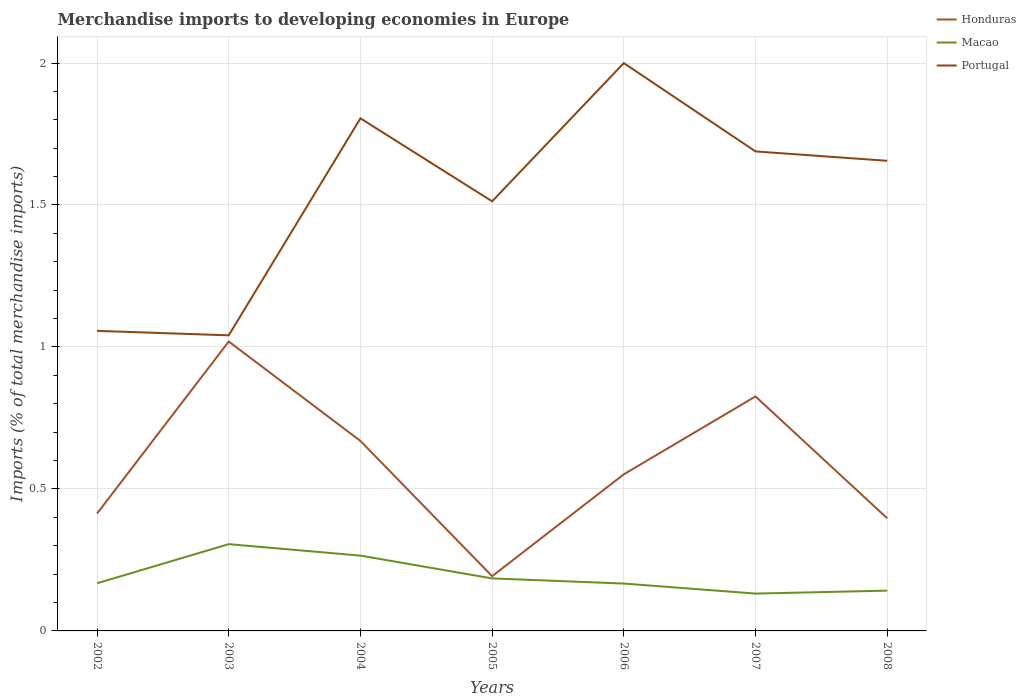How many different coloured lines are there?
Your response must be concise. 3. Does the line corresponding to Honduras intersect with the line corresponding to Portugal?
Your response must be concise. No. Across all years, what is the maximum percentage total merchandise imports in Portugal?
Your answer should be compact. 1.04. In which year was the percentage total merchandise imports in Honduras maximum?
Offer a terse response. 2005. What is the total percentage total merchandise imports in Macao in the graph?
Ensure brevity in your answer.  0.02. What is the difference between the highest and the second highest percentage total merchandise imports in Portugal?
Your answer should be compact. 0.96. What is the difference between the highest and the lowest percentage total merchandise imports in Portugal?
Make the answer very short. 4. Is the percentage total merchandise imports in Portugal strictly greater than the percentage total merchandise imports in Honduras over the years?
Ensure brevity in your answer.  No. How many years are there in the graph?
Give a very brief answer. 7. Does the graph contain any zero values?
Give a very brief answer. No. Where does the legend appear in the graph?
Your answer should be compact. Top right. How many legend labels are there?
Keep it short and to the point. 3. How are the legend labels stacked?
Ensure brevity in your answer.  Vertical. What is the title of the graph?
Make the answer very short. Merchandise imports to developing economies in Europe. What is the label or title of the Y-axis?
Provide a succinct answer. Imports (% of total merchandise imports). What is the Imports (% of total merchandise imports) in Honduras in 2002?
Make the answer very short. 0.41. What is the Imports (% of total merchandise imports) in Macao in 2002?
Keep it short and to the point. 0.17. What is the Imports (% of total merchandise imports) in Portugal in 2002?
Your answer should be very brief. 1.06. What is the Imports (% of total merchandise imports) in Honduras in 2003?
Offer a terse response. 1.02. What is the Imports (% of total merchandise imports) of Macao in 2003?
Provide a short and direct response. 0.31. What is the Imports (% of total merchandise imports) in Portugal in 2003?
Give a very brief answer. 1.04. What is the Imports (% of total merchandise imports) in Honduras in 2004?
Your answer should be compact. 0.67. What is the Imports (% of total merchandise imports) in Macao in 2004?
Make the answer very short. 0.27. What is the Imports (% of total merchandise imports) in Portugal in 2004?
Provide a succinct answer. 1.81. What is the Imports (% of total merchandise imports) in Honduras in 2005?
Offer a terse response. 0.19. What is the Imports (% of total merchandise imports) in Macao in 2005?
Give a very brief answer. 0.18. What is the Imports (% of total merchandise imports) in Portugal in 2005?
Make the answer very short. 1.51. What is the Imports (% of total merchandise imports) in Honduras in 2006?
Give a very brief answer. 0.55. What is the Imports (% of total merchandise imports) in Macao in 2006?
Make the answer very short. 0.17. What is the Imports (% of total merchandise imports) in Portugal in 2006?
Make the answer very short. 2. What is the Imports (% of total merchandise imports) in Honduras in 2007?
Offer a very short reply. 0.83. What is the Imports (% of total merchandise imports) in Macao in 2007?
Your answer should be compact. 0.13. What is the Imports (% of total merchandise imports) of Portugal in 2007?
Your answer should be very brief. 1.69. What is the Imports (% of total merchandise imports) in Honduras in 2008?
Make the answer very short. 0.4. What is the Imports (% of total merchandise imports) in Macao in 2008?
Your answer should be compact. 0.14. What is the Imports (% of total merchandise imports) in Portugal in 2008?
Provide a short and direct response. 1.66. Across all years, what is the maximum Imports (% of total merchandise imports) of Honduras?
Provide a succinct answer. 1.02. Across all years, what is the maximum Imports (% of total merchandise imports) in Macao?
Give a very brief answer. 0.31. Across all years, what is the maximum Imports (% of total merchandise imports) of Portugal?
Your answer should be very brief. 2. Across all years, what is the minimum Imports (% of total merchandise imports) in Honduras?
Your answer should be very brief. 0.19. Across all years, what is the minimum Imports (% of total merchandise imports) of Macao?
Provide a short and direct response. 0.13. Across all years, what is the minimum Imports (% of total merchandise imports) in Portugal?
Make the answer very short. 1.04. What is the total Imports (% of total merchandise imports) of Honduras in the graph?
Offer a very short reply. 4.07. What is the total Imports (% of total merchandise imports) in Macao in the graph?
Your answer should be very brief. 1.36. What is the total Imports (% of total merchandise imports) of Portugal in the graph?
Give a very brief answer. 10.76. What is the difference between the Imports (% of total merchandise imports) in Honduras in 2002 and that in 2003?
Keep it short and to the point. -0.61. What is the difference between the Imports (% of total merchandise imports) of Macao in 2002 and that in 2003?
Your answer should be compact. -0.14. What is the difference between the Imports (% of total merchandise imports) of Portugal in 2002 and that in 2003?
Make the answer very short. 0.02. What is the difference between the Imports (% of total merchandise imports) in Honduras in 2002 and that in 2004?
Make the answer very short. -0.26. What is the difference between the Imports (% of total merchandise imports) in Macao in 2002 and that in 2004?
Keep it short and to the point. -0.1. What is the difference between the Imports (% of total merchandise imports) of Portugal in 2002 and that in 2004?
Provide a short and direct response. -0.75. What is the difference between the Imports (% of total merchandise imports) in Honduras in 2002 and that in 2005?
Offer a terse response. 0.22. What is the difference between the Imports (% of total merchandise imports) in Macao in 2002 and that in 2005?
Keep it short and to the point. -0.02. What is the difference between the Imports (% of total merchandise imports) in Portugal in 2002 and that in 2005?
Provide a succinct answer. -0.46. What is the difference between the Imports (% of total merchandise imports) of Honduras in 2002 and that in 2006?
Your answer should be compact. -0.14. What is the difference between the Imports (% of total merchandise imports) in Macao in 2002 and that in 2006?
Offer a terse response. 0. What is the difference between the Imports (% of total merchandise imports) of Portugal in 2002 and that in 2006?
Offer a very short reply. -0.94. What is the difference between the Imports (% of total merchandise imports) in Honduras in 2002 and that in 2007?
Give a very brief answer. -0.41. What is the difference between the Imports (% of total merchandise imports) in Macao in 2002 and that in 2007?
Your answer should be compact. 0.04. What is the difference between the Imports (% of total merchandise imports) in Portugal in 2002 and that in 2007?
Provide a short and direct response. -0.63. What is the difference between the Imports (% of total merchandise imports) of Honduras in 2002 and that in 2008?
Provide a succinct answer. 0.02. What is the difference between the Imports (% of total merchandise imports) in Macao in 2002 and that in 2008?
Make the answer very short. 0.03. What is the difference between the Imports (% of total merchandise imports) in Portugal in 2002 and that in 2008?
Ensure brevity in your answer.  -0.6. What is the difference between the Imports (% of total merchandise imports) of Honduras in 2003 and that in 2004?
Offer a very short reply. 0.35. What is the difference between the Imports (% of total merchandise imports) in Macao in 2003 and that in 2004?
Your answer should be compact. 0.04. What is the difference between the Imports (% of total merchandise imports) in Portugal in 2003 and that in 2004?
Provide a succinct answer. -0.76. What is the difference between the Imports (% of total merchandise imports) of Honduras in 2003 and that in 2005?
Provide a short and direct response. 0.83. What is the difference between the Imports (% of total merchandise imports) in Macao in 2003 and that in 2005?
Your response must be concise. 0.12. What is the difference between the Imports (% of total merchandise imports) of Portugal in 2003 and that in 2005?
Your response must be concise. -0.47. What is the difference between the Imports (% of total merchandise imports) of Honduras in 2003 and that in 2006?
Offer a terse response. 0.47. What is the difference between the Imports (% of total merchandise imports) of Macao in 2003 and that in 2006?
Offer a terse response. 0.14. What is the difference between the Imports (% of total merchandise imports) of Portugal in 2003 and that in 2006?
Your answer should be very brief. -0.96. What is the difference between the Imports (% of total merchandise imports) of Honduras in 2003 and that in 2007?
Make the answer very short. 0.19. What is the difference between the Imports (% of total merchandise imports) in Macao in 2003 and that in 2007?
Your response must be concise. 0.17. What is the difference between the Imports (% of total merchandise imports) in Portugal in 2003 and that in 2007?
Your answer should be compact. -0.65. What is the difference between the Imports (% of total merchandise imports) in Honduras in 2003 and that in 2008?
Offer a terse response. 0.62. What is the difference between the Imports (% of total merchandise imports) in Macao in 2003 and that in 2008?
Keep it short and to the point. 0.16. What is the difference between the Imports (% of total merchandise imports) in Portugal in 2003 and that in 2008?
Provide a succinct answer. -0.61. What is the difference between the Imports (% of total merchandise imports) of Honduras in 2004 and that in 2005?
Offer a very short reply. 0.48. What is the difference between the Imports (% of total merchandise imports) of Macao in 2004 and that in 2005?
Offer a terse response. 0.08. What is the difference between the Imports (% of total merchandise imports) in Portugal in 2004 and that in 2005?
Provide a short and direct response. 0.29. What is the difference between the Imports (% of total merchandise imports) in Honduras in 2004 and that in 2006?
Make the answer very short. 0.12. What is the difference between the Imports (% of total merchandise imports) of Macao in 2004 and that in 2006?
Your answer should be compact. 0.1. What is the difference between the Imports (% of total merchandise imports) in Portugal in 2004 and that in 2006?
Ensure brevity in your answer.  -0.19. What is the difference between the Imports (% of total merchandise imports) in Honduras in 2004 and that in 2007?
Give a very brief answer. -0.16. What is the difference between the Imports (% of total merchandise imports) of Macao in 2004 and that in 2007?
Offer a terse response. 0.13. What is the difference between the Imports (% of total merchandise imports) of Portugal in 2004 and that in 2007?
Your response must be concise. 0.12. What is the difference between the Imports (% of total merchandise imports) in Honduras in 2004 and that in 2008?
Provide a succinct answer. 0.27. What is the difference between the Imports (% of total merchandise imports) of Macao in 2004 and that in 2008?
Provide a short and direct response. 0.12. What is the difference between the Imports (% of total merchandise imports) in Portugal in 2004 and that in 2008?
Give a very brief answer. 0.15. What is the difference between the Imports (% of total merchandise imports) of Honduras in 2005 and that in 2006?
Offer a very short reply. -0.36. What is the difference between the Imports (% of total merchandise imports) in Macao in 2005 and that in 2006?
Ensure brevity in your answer.  0.02. What is the difference between the Imports (% of total merchandise imports) in Portugal in 2005 and that in 2006?
Make the answer very short. -0.49. What is the difference between the Imports (% of total merchandise imports) in Honduras in 2005 and that in 2007?
Provide a succinct answer. -0.63. What is the difference between the Imports (% of total merchandise imports) in Macao in 2005 and that in 2007?
Your answer should be compact. 0.05. What is the difference between the Imports (% of total merchandise imports) of Portugal in 2005 and that in 2007?
Your response must be concise. -0.18. What is the difference between the Imports (% of total merchandise imports) in Honduras in 2005 and that in 2008?
Make the answer very short. -0.2. What is the difference between the Imports (% of total merchandise imports) in Macao in 2005 and that in 2008?
Offer a terse response. 0.04. What is the difference between the Imports (% of total merchandise imports) of Portugal in 2005 and that in 2008?
Your answer should be very brief. -0.14. What is the difference between the Imports (% of total merchandise imports) of Honduras in 2006 and that in 2007?
Provide a short and direct response. -0.27. What is the difference between the Imports (% of total merchandise imports) of Macao in 2006 and that in 2007?
Your answer should be compact. 0.04. What is the difference between the Imports (% of total merchandise imports) in Portugal in 2006 and that in 2007?
Keep it short and to the point. 0.31. What is the difference between the Imports (% of total merchandise imports) in Honduras in 2006 and that in 2008?
Offer a very short reply. 0.15. What is the difference between the Imports (% of total merchandise imports) in Macao in 2006 and that in 2008?
Keep it short and to the point. 0.02. What is the difference between the Imports (% of total merchandise imports) of Portugal in 2006 and that in 2008?
Make the answer very short. 0.34. What is the difference between the Imports (% of total merchandise imports) in Honduras in 2007 and that in 2008?
Give a very brief answer. 0.43. What is the difference between the Imports (% of total merchandise imports) of Macao in 2007 and that in 2008?
Offer a very short reply. -0.01. What is the difference between the Imports (% of total merchandise imports) of Portugal in 2007 and that in 2008?
Offer a very short reply. 0.03. What is the difference between the Imports (% of total merchandise imports) of Honduras in 2002 and the Imports (% of total merchandise imports) of Macao in 2003?
Ensure brevity in your answer.  0.11. What is the difference between the Imports (% of total merchandise imports) in Honduras in 2002 and the Imports (% of total merchandise imports) in Portugal in 2003?
Give a very brief answer. -0.63. What is the difference between the Imports (% of total merchandise imports) in Macao in 2002 and the Imports (% of total merchandise imports) in Portugal in 2003?
Keep it short and to the point. -0.87. What is the difference between the Imports (% of total merchandise imports) in Honduras in 2002 and the Imports (% of total merchandise imports) in Macao in 2004?
Keep it short and to the point. 0.15. What is the difference between the Imports (% of total merchandise imports) in Honduras in 2002 and the Imports (% of total merchandise imports) in Portugal in 2004?
Give a very brief answer. -1.39. What is the difference between the Imports (% of total merchandise imports) of Macao in 2002 and the Imports (% of total merchandise imports) of Portugal in 2004?
Provide a succinct answer. -1.64. What is the difference between the Imports (% of total merchandise imports) of Honduras in 2002 and the Imports (% of total merchandise imports) of Macao in 2005?
Offer a very short reply. 0.23. What is the difference between the Imports (% of total merchandise imports) of Honduras in 2002 and the Imports (% of total merchandise imports) of Portugal in 2005?
Provide a succinct answer. -1.1. What is the difference between the Imports (% of total merchandise imports) in Macao in 2002 and the Imports (% of total merchandise imports) in Portugal in 2005?
Provide a short and direct response. -1.35. What is the difference between the Imports (% of total merchandise imports) of Honduras in 2002 and the Imports (% of total merchandise imports) of Macao in 2006?
Make the answer very short. 0.25. What is the difference between the Imports (% of total merchandise imports) in Honduras in 2002 and the Imports (% of total merchandise imports) in Portugal in 2006?
Provide a succinct answer. -1.59. What is the difference between the Imports (% of total merchandise imports) in Macao in 2002 and the Imports (% of total merchandise imports) in Portugal in 2006?
Provide a short and direct response. -1.83. What is the difference between the Imports (% of total merchandise imports) in Honduras in 2002 and the Imports (% of total merchandise imports) in Macao in 2007?
Ensure brevity in your answer.  0.28. What is the difference between the Imports (% of total merchandise imports) of Honduras in 2002 and the Imports (% of total merchandise imports) of Portugal in 2007?
Your answer should be compact. -1.28. What is the difference between the Imports (% of total merchandise imports) of Macao in 2002 and the Imports (% of total merchandise imports) of Portugal in 2007?
Make the answer very short. -1.52. What is the difference between the Imports (% of total merchandise imports) in Honduras in 2002 and the Imports (% of total merchandise imports) in Macao in 2008?
Provide a short and direct response. 0.27. What is the difference between the Imports (% of total merchandise imports) in Honduras in 2002 and the Imports (% of total merchandise imports) in Portugal in 2008?
Provide a succinct answer. -1.24. What is the difference between the Imports (% of total merchandise imports) in Macao in 2002 and the Imports (% of total merchandise imports) in Portugal in 2008?
Give a very brief answer. -1.49. What is the difference between the Imports (% of total merchandise imports) of Honduras in 2003 and the Imports (% of total merchandise imports) of Macao in 2004?
Your answer should be very brief. 0.75. What is the difference between the Imports (% of total merchandise imports) in Honduras in 2003 and the Imports (% of total merchandise imports) in Portugal in 2004?
Offer a terse response. -0.79. What is the difference between the Imports (% of total merchandise imports) in Macao in 2003 and the Imports (% of total merchandise imports) in Portugal in 2004?
Offer a terse response. -1.5. What is the difference between the Imports (% of total merchandise imports) in Honduras in 2003 and the Imports (% of total merchandise imports) in Macao in 2005?
Keep it short and to the point. 0.83. What is the difference between the Imports (% of total merchandise imports) of Honduras in 2003 and the Imports (% of total merchandise imports) of Portugal in 2005?
Make the answer very short. -0.49. What is the difference between the Imports (% of total merchandise imports) in Macao in 2003 and the Imports (% of total merchandise imports) in Portugal in 2005?
Give a very brief answer. -1.21. What is the difference between the Imports (% of total merchandise imports) of Honduras in 2003 and the Imports (% of total merchandise imports) of Macao in 2006?
Your answer should be very brief. 0.85. What is the difference between the Imports (% of total merchandise imports) of Honduras in 2003 and the Imports (% of total merchandise imports) of Portugal in 2006?
Ensure brevity in your answer.  -0.98. What is the difference between the Imports (% of total merchandise imports) in Macao in 2003 and the Imports (% of total merchandise imports) in Portugal in 2006?
Keep it short and to the point. -1.69. What is the difference between the Imports (% of total merchandise imports) in Honduras in 2003 and the Imports (% of total merchandise imports) in Macao in 2007?
Make the answer very short. 0.89. What is the difference between the Imports (% of total merchandise imports) of Honduras in 2003 and the Imports (% of total merchandise imports) of Portugal in 2007?
Make the answer very short. -0.67. What is the difference between the Imports (% of total merchandise imports) in Macao in 2003 and the Imports (% of total merchandise imports) in Portugal in 2007?
Your answer should be compact. -1.38. What is the difference between the Imports (% of total merchandise imports) of Honduras in 2003 and the Imports (% of total merchandise imports) of Macao in 2008?
Ensure brevity in your answer.  0.88. What is the difference between the Imports (% of total merchandise imports) of Honduras in 2003 and the Imports (% of total merchandise imports) of Portugal in 2008?
Provide a succinct answer. -0.64. What is the difference between the Imports (% of total merchandise imports) of Macao in 2003 and the Imports (% of total merchandise imports) of Portugal in 2008?
Your response must be concise. -1.35. What is the difference between the Imports (% of total merchandise imports) in Honduras in 2004 and the Imports (% of total merchandise imports) in Macao in 2005?
Provide a short and direct response. 0.48. What is the difference between the Imports (% of total merchandise imports) in Honduras in 2004 and the Imports (% of total merchandise imports) in Portugal in 2005?
Provide a short and direct response. -0.84. What is the difference between the Imports (% of total merchandise imports) in Macao in 2004 and the Imports (% of total merchandise imports) in Portugal in 2005?
Offer a very short reply. -1.25. What is the difference between the Imports (% of total merchandise imports) of Honduras in 2004 and the Imports (% of total merchandise imports) of Macao in 2006?
Give a very brief answer. 0.5. What is the difference between the Imports (% of total merchandise imports) of Honduras in 2004 and the Imports (% of total merchandise imports) of Portugal in 2006?
Provide a succinct answer. -1.33. What is the difference between the Imports (% of total merchandise imports) in Macao in 2004 and the Imports (% of total merchandise imports) in Portugal in 2006?
Your answer should be very brief. -1.73. What is the difference between the Imports (% of total merchandise imports) in Honduras in 2004 and the Imports (% of total merchandise imports) in Macao in 2007?
Offer a terse response. 0.54. What is the difference between the Imports (% of total merchandise imports) of Honduras in 2004 and the Imports (% of total merchandise imports) of Portugal in 2007?
Your answer should be very brief. -1.02. What is the difference between the Imports (% of total merchandise imports) of Macao in 2004 and the Imports (% of total merchandise imports) of Portugal in 2007?
Offer a terse response. -1.42. What is the difference between the Imports (% of total merchandise imports) of Honduras in 2004 and the Imports (% of total merchandise imports) of Macao in 2008?
Provide a succinct answer. 0.53. What is the difference between the Imports (% of total merchandise imports) in Honduras in 2004 and the Imports (% of total merchandise imports) in Portugal in 2008?
Provide a succinct answer. -0.99. What is the difference between the Imports (% of total merchandise imports) of Macao in 2004 and the Imports (% of total merchandise imports) of Portugal in 2008?
Offer a very short reply. -1.39. What is the difference between the Imports (% of total merchandise imports) of Honduras in 2005 and the Imports (% of total merchandise imports) of Macao in 2006?
Provide a succinct answer. 0.03. What is the difference between the Imports (% of total merchandise imports) of Honduras in 2005 and the Imports (% of total merchandise imports) of Portugal in 2006?
Provide a succinct answer. -1.81. What is the difference between the Imports (% of total merchandise imports) of Macao in 2005 and the Imports (% of total merchandise imports) of Portugal in 2006?
Give a very brief answer. -1.81. What is the difference between the Imports (% of total merchandise imports) of Honduras in 2005 and the Imports (% of total merchandise imports) of Macao in 2007?
Offer a very short reply. 0.06. What is the difference between the Imports (% of total merchandise imports) in Honduras in 2005 and the Imports (% of total merchandise imports) in Portugal in 2007?
Provide a short and direct response. -1.5. What is the difference between the Imports (% of total merchandise imports) in Macao in 2005 and the Imports (% of total merchandise imports) in Portugal in 2007?
Keep it short and to the point. -1.5. What is the difference between the Imports (% of total merchandise imports) in Honduras in 2005 and the Imports (% of total merchandise imports) in Macao in 2008?
Provide a succinct answer. 0.05. What is the difference between the Imports (% of total merchandise imports) in Honduras in 2005 and the Imports (% of total merchandise imports) in Portugal in 2008?
Your response must be concise. -1.46. What is the difference between the Imports (% of total merchandise imports) in Macao in 2005 and the Imports (% of total merchandise imports) in Portugal in 2008?
Provide a short and direct response. -1.47. What is the difference between the Imports (% of total merchandise imports) in Honduras in 2006 and the Imports (% of total merchandise imports) in Macao in 2007?
Keep it short and to the point. 0.42. What is the difference between the Imports (% of total merchandise imports) in Honduras in 2006 and the Imports (% of total merchandise imports) in Portugal in 2007?
Your response must be concise. -1.14. What is the difference between the Imports (% of total merchandise imports) in Macao in 2006 and the Imports (% of total merchandise imports) in Portugal in 2007?
Ensure brevity in your answer.  -1.52. What is the difference between the Imports (% of total merchandise imports) in Honduras in 2006 and the Imports (% of total merchandise imports) in Macao in 2008?
Keep it short and to the point. 0.41. What is the difference between the Imports (% of total merchandise imports) in Honduras in 2006 and the Imports (% of total merchandise imports) in Portugal in 2008?
Provide a short and direct response. -1.1. What is the difference between the Imports (% of total merchandise imports) of Macao in 2006 and the Imports (% of total merchandise imports) of Portugal in 2008?
Give a very brief answer. -1.49. What is the difference between the Imports (% of total merchandise imports) in Honduras in 2007 and the Imports (% of total merchandise imports) in Macao in 2008?
Offer a very short reply. 0.68. What is the difference between the Imports (% of total merchandise imports) in Honduras in 2007 and the Imports (% of total merchandise imports) in Portugal in 2008?
Give a very brief answer. -0.83. What is the difference between the Imports (% of total merchandise imports) in Macao in 2007 and the Imports (% of total merchandise imports) in Portugal in 2008?
Your response must be concise. -1.52. What is the average Imports (% of total merchandise imports) of Honduras per year?
Your response must be concise. 0.58. What is the average Imports (% of total merchandise imports) in Macao per year?
Your answer should be compact. 0.19. What is the average Imports (% of total merchandise imports) of Portugal per year?
Offer a terse response. 1.54. In the year 2002, what is the difference between the Imports (% of total merchandise imports) of Honduras and Imports (% of total merchandise imports) of Macao?
Keep it short and to the point. 0.25. In the year 2002, what is the difference between the Imports (% of total merchandise imports) in Honduras and Imports (% of total merchandise imports) in Portugal?
Provide a short and direct response. -0.64. In the year 2002, what is the difference between the Imports (% of total merchandise imports) in Macao and Imports (% of total merchandise imports) in Portugal?
Your answer should be very brief. -0.89. In the year 2003, what is the difference between the Imports (% of total merchandise imports) in Honduras and Imports (% of total merchandise imports) in Macao?
Your response must be concise. 0.71. In the year 2003, what is the difference between the Imports (% of total merchandise imports) in Honduras and Imports (% of total merchandise imports) in Portugal?
Provide a short and direct response. -0.02. In the year 2003, what is the difference between the Imports (% of total merchandise imports) of Macao and Imports (% of total merchandise imports) of Portugal?
Your answer should be very brief. -0.74. In the year 2004, what is the difference between the Imports (% of total merchandise imports) in Honduras and Imports (% of total merchandise imports) in Macao?
Ensure brevity in your answer.  0.4. In the year 2004, what is the difference between the Imports (% of total merchandise imports) in Honduras and Imports (% of total merchandise imports) in Portugal?
Offer a terse response. -1.14. In the year 2004, what is the difference between the Imports (% of total merchandise imports) in Macao and Imports (% of total merchandise imports) in Portugal?
Keep it short and to the point. -1.54. In the year 2005, what is the difference between the Imports (% of total merchandise imports) in Honduras and Imports (% of total merchandise imports) in Macao?
Ensure brevity in your answer.  0.01. In the year 2005, what is the difference between the Imports (% of total merchandise imports) in Honduras and Imports (% of total merchandise imports) in Portugal?
Offer a very short reply. -1.32. In the year 2005, what is the difference between the Imports (% of total merchandise imports) in Macao and Imports (% of total merchandise imports) in Portugal?
Make the answer very short. -1.33. In the year 2006, what is the difference between the Imports (% of total merchandise imports) of Honduras and Imports (% of total merchandise imports) of Macao?
Offer a terse response. 0.38. In the year 2006, what is the difference between the Imports (% of total merchandise imports) in Honduras and Imports (% of total merchandise imports) in Portugal?
Give a very brief answer. -1.45. In the year 2006, what is the difference between the Imports (% of total merchandise imports) of Macao and Imports (% of total merchandise imports) of Portugal?
Your answer should be very brief. -1.83. In the year 2007, what is the difference between the Imports (% of total merchandise imports) in Honduras and Imports (% of total merchandise imports) in Macao?
Ensure brevity in your answer.  0.69. In the year 2007, what is the difference between the Imports (% of total merchandise imports) in Honduras and Imports (% of total merchandise imports) in Portugal?
Offer a terse response. -0.86. In the year 2007, what is the difference between the Imports (% of total merchandise imports) of Macao and Imports (% of total merchandise imports) of Portugal?
Your answer should be compact. -1.56. In the year 2008, what is the difference between the Imports (% of total merchandise imports) of Honduras and Imports (% of total merchandise imports) of Macao?
Your answer should be compact. 0.25. In the year 2008, what is the difference between the Imports (% of total merchandise imports) in Honduras and Imports (% of total merchandise imports) in Portugal?
Offer a very short reply. -1.26. In the year 2008, what is the difference between the Imports (% of total merchandise imports) of Macao and Imports (% of total merchandise imports) of Portugal?
Give a very brief answer. -1.51. What is the ratio of the Imports (% of total merchandise imports) in Honduras in 2002 to that in 2003?
Your response must be concise. 0.41. What is the ratio of the Imports (% of total merchandise imports) in Macao in 2002 to that in 2003?
Give a very brief answer. 0.55. What is the ratio of the Imports (% of total merchandise imports) in Portugal in 2002 to that in 2003?
Offer a terse response. 1.02. What is the ratio of the Imports (% of total merchandise imports) in Honduras in 2002 to that in 2004?
Your response must be concise. 0.62. What is the ratio of the Imports (% of total merchandise imports) of Macao in 2002 to that in 2004?
Your answer should be compact. 0.63. What is the ratio of the Imports (% of total merchandise imports) in Portugal in 2002 to that in 2004?
Provide a short and direct response. 0.59. What is the ratio of the Imports (% of total merchandise imports) of Honduras in 2002 to that in 2005?
Make the answer very short. 2.14. What is the ratio of the Imports (% of total merchandise imports) in Macao in 2002 to that in 2005?
Make the answer very short. 0.91. What is the ratio of the Imports (% of total merchandise imports) of Portugal in 2002 to that in 2005?
Offer a terse response. 0.7. What is the ratio of the Imports (% of total merchandise imports) in Honduras in 2002 to that in 2006?
Give a very brief answer. 0.75. What is the ratio of the Imports (% of total merchandise imports) of Macao in 2002 to that in 2006?
Make the answer very short. 1.01. What is the ratio of the Imports (% of total merchandise imports) of Portugal in 2002 to that in 2006?
Ensure brevity in your answer.  0.53. What is the ratio of the Imports (% of total merchandise imports) of Honduras in 2002 to that in 2007?
Keep it short and to the point. 0.5. What is the ratio of the Imports (% of total merchandise imports) of Macao in 2002 to that in 2007?
Your answer should be compact. 1.28. What is the ratio of the Imports (% of total merchandise imports) in Portugal in 2002 to that in 2007?
Ensure brevity in your answer.  0.63. What is the ratio of the Imports (% of total merchandise imports) of Honduras in 2002 to that in 2008?
Ensure brevity in your answer.  1.04. What is the ratio of the Imports (% of total merchandise imports) of Macao in 2002 to that in 2008?
Provide a succinct answer. 1.18. What is the ratio of the Imports (% of total merchandise imports) of Portugal in 2002 to that in 2008?
Ensure brevity in your answer.  0.64. What is the ratio of the Imports (% of total merchandise imports) of Honduras in 2003 to that in 2004?
Ensure brevity in your answer.  1.52. What is the ratio of the Imports (% of total merchandise imports) in Macao in 2003 to that in 2004?
Provide a succinct answer. 1.15. What is the ratio of the Imports (% of total merchandise imports) of Portugal in 2003 to that in 2004?
Offer a terse response. 0.58. What is the ratio of the Imports (% of total merchandise imports) in Honduras in 2003 to that in 2005?
Provide a short and direct response. 5.29. What is the ratio of the Imports (% of total merchandise imports) of Macao in 2003 to that in 2005?
Offer a very short reply. 1.65. What is the ratio of the Imports (% of total merchandise imports) of Portugal in 2003 to that in 2005?
Offer a terse response. 0.69. What is the ratio of the Imports (% of total merchandise imports) of Honduras in 2003 to that in 2006?
Ensure brevity in your answer.  1.85. What is the ratio of the Imports (% of total merchandise imports) in Macao in 2003 to that in 2006?
Provide a succinct answer. 1.83. What is the ratio of the Imports (% of total merchandise imports) in Portugal in 2003 to that in 2006?
Keep it short and to the point. 0.52. What is the ratio of the Imports (% of total merchandise imports) of Honduras in 2003 to that in 2007?
Ensure brevity in your answer.  1.23. What is the ratio of the Imports (% of total merchandise imports) in Macao in 2003 to that in 2007?
Make the answer very short. 2.32. What is the ratio of the Imports (% of total merchandise imports) in Portugal in 2003 to that in 2007?
Your answer should be compact. 0.62. What is the ratio of the Imports (% of total merchandise imports) in Honduras in 2003 to that in 2008?
Make the answer very short. 2.57. What is the ratio of the Imports (% of total merchandise imports) of Macao in 2003 to that in 2008?
Your answer should be compact. 2.15. What is the ratio of the Imports (% of total merchandise imports) in Portugal in 2003 to that in 2008?
Your answer should be compact. 0.63. What is the ratio of the Imports (% of total merchandise imports) of Honduras in 2004 to that in 2005?
Your answer should be compact. 3.47. What is the ratio of the Imports (% of total merchandise imports) of Macao in 2004 to that in 2005?
Keep it short and to the point. 1.43. What is the ratio of the Imports (% of total merchandise imports) of Portugal in 2004 to that in 2005?
Give a very brief answer. 1.19. What is the ratio of the Imports (% of total merchandise imports) in Honduras in 2004 to that in 2006?
Offer a terse response. 1.21. What is the ratio of the Imports (% of total merchandise imports) of Macao in 2004 to that in 2006?
Give a very brief answer. 1.59. What is the ratio of the Imports (% of total merchandise imports) in Portugal in 2004 to that in 2006?
Your answer should be very brief. 0.9. What is the ratio of the Imports (% of total merchandise imports) of Honduras in 2004 to that in 2007?
Your response must be concise. 0.81. What is the ratio of the Imports (% of total merchandise imports) in Macao in 2004 to that in 2007?
Your response must be concise. 2.02. What is the ratio of the Imports (% of total merchandise imports) in Portugal in 2004 to that in 2007?
Your answer should be very brief. 1.07. What is the ratio of the Imports (% of total merchandise imports) of Honduras in 2004 to that in 2008?
Offer a terse response. 1.69. What is the ratio of the Imports (% of total merchandise imports) of Macao in 2004 to that in 2008?
Give a very brief answer. 1.87. What is the ratio of the Imports (% of total merchandise imports) in Portugal in 2004 to that in 2008?
Your answer should be compact. 1.09. What is the ratio of the Imports (% of total merchandise imports) of Honduras in 2005 to that in 2006?
Make the answer very short. 0.35. What is the ratio of the Imports (% of total merchandise imports) in Macao in 2005 to that in 2006?
Your response must be concise. 1.11. What is the ratio of the Imports (% of total merchandise imports) in Portugal in 2005 to that in 2006?
Give a very brief answer. 0.76. What is the ratio of the Imports (% of total merchandise imports) in Honduras in 2005 to that in 2007?
Your answer should be compact. 0.23. What is the ratio of the Imports (% of total merchandise imports) of Macao in 2005 to that in 2007?
Provide a succinct answer. 1.41. What is the ratio of the Imports (% of total merchandise imports) in Portugal in 2005 to that in 2007?
Your answer should be compact. 0.9. What is the ratio of the Imports (% of total merchandise imports) in Honduras in 2005 to that in 2008?
Keep it short and to the point. 0.49. What is the ratio of the Imports (% of total merchandise imports) in Macao in 2005 to that in 2008?
Offer a very short reply. 1.3. What is the ratio of the Imports (% of total merchandise imports) of Portugal in 2005 to that in 2008?
Give a very brief answer. 0.91. What is the ratio of the Imports (% of total merchandise imports) of Honduras in 2006 to that in 2007?
Give a very brief answer. 0.67. What is the ratio of the Imports (% of total merchandise imports) of Macao in 2006 to that in 2007?
Provide a short and direct response. 1.27. What is the ratio of the Imports (% of total merchandise imports) in Portugal in 2006 to that in 2007?
Offer a terse response. 1.18. What is the ratio of the Imports (% of total merchandise imports) of Honduras in 2006 to that in 2008?
Ensure brevity in your answer.  1.39. What is the ratio of the Imports (% of total merchandise imports) of Macao in 2006 to that in 2008?
Make the answer very short. 1.18. What is the ratio of the Imports (% of total merchandise imports) of Portugal in 2006 to that in 2008?
Offer a terse response. 1.21. What is the ratio of the Imports (% of total merchandise imports) in Honduras in 2007 to that in 2008?
Offer a very short reply. 2.08. What is the ratio of the Imports (% of total merchandise imports) of Macao in 2007 to that in 2008?
Provide a succinct answer. 0.93. What is the ratio of the Imports (% of total merchandise imports) of Portugal in 2007 to that in 2008?
Your answer should be compact. 1.02. What is the difference between the highest and the second highest Imports (% of total merchandise imports) of Honduras?
Make the answer very short. 0.19. What is the difference between the highest and the second highest Imports (% of total merchandise imports) in Macao?
Provide a short and direct response. 0.04. What is the difference between the highest and the second highest Imports (% of total merchandise imports) in Portugal?
Give a very brief answer. 0.19. What is the difference between the highest and the lowest Imports (% of total merchandise imports) of Honduras?
Make the answer very short. 0.83. What is the difference between the highest and the lowest Imports (% of total merchandise imports) in Macao?
Provide a short and direct response. 0.17. What is the difference between the highest and the lowest Imports (% of total merchandise imports) in Portugal?
Your answer should be very brief. 0.96. 